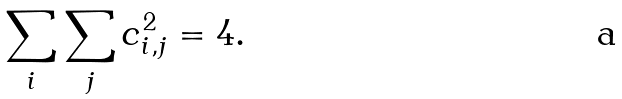<formula> <loc_0><loc_0><loc_500><loc_500>\sum _ { i } \sum _ { j } c _ { i , j } ^ { 2 } = 4 .</formula> 